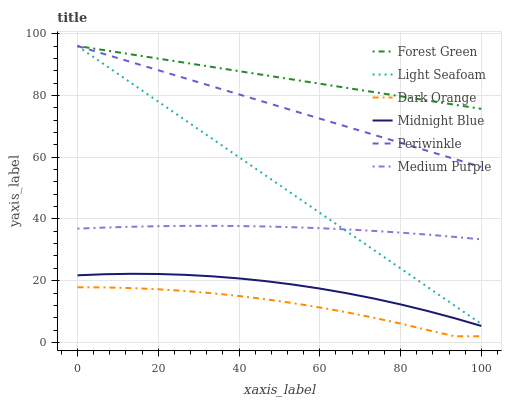Does Dark Orange have the minimum area under the curve?
Answer yes or no. Yes. Does Forest Green have the maximum area under the curve?
Answer yes or no. Yes. Does Midnight Blue have the minimum area under the curve?
Answer yes or no. No. Does Midnight Blue have the maximum area under the curve?
Answer yes or no. No. Is Light Seafoam the smoothest?
Answer yes or no. Yes. Is Dark Orange the roughest?
Answer yes or no. Yes. Is Midnight Blue the smoothest?
Answer yes or no. No. Is Midnight Blue the roughest?
Answer yes or no. No. Does Dark Orange have the lowest value?
Answer yes or no. Yes. Does Midnight Blue have the lowest value?
Answer yes or no. No. Does Light Seafoam have the highest value?
Answer yes or no. Yes. Does Midnight Blue have the highest value?
Answer yes or no. No. Is Midnight Blue less than Forest Green?
Answer yes or no. Yes. Is Light Seafoam greater than Midnight Blue?
Answer yes or no. Yes. Does Light Seafoam intersect Periwinkle?
Answer yes or no. Yes. Is Light Seafoam less than Periwinkle?
Answer yes or no. No. Is Light Seafoam greater than Periwinkle?
Answer yes or no. No. Does Midnight Blue intersect Forest Green?
Answer yes or no. No. 